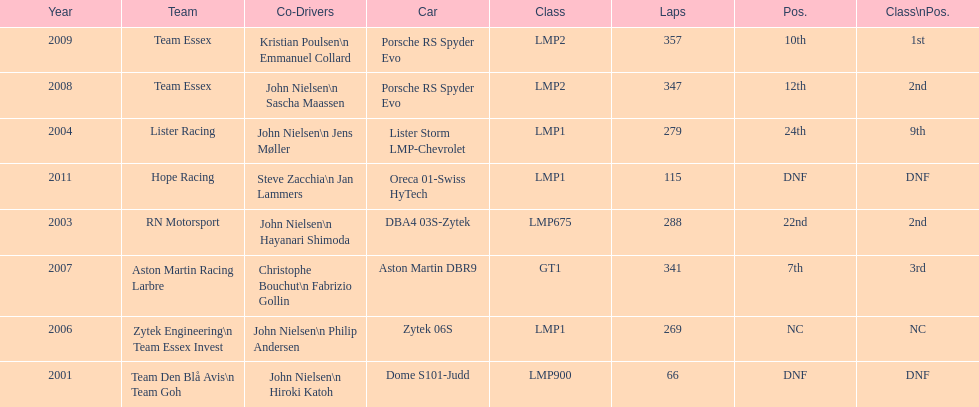Who was john nielsen co-driver for team lister in 2004? Jens Møller. 